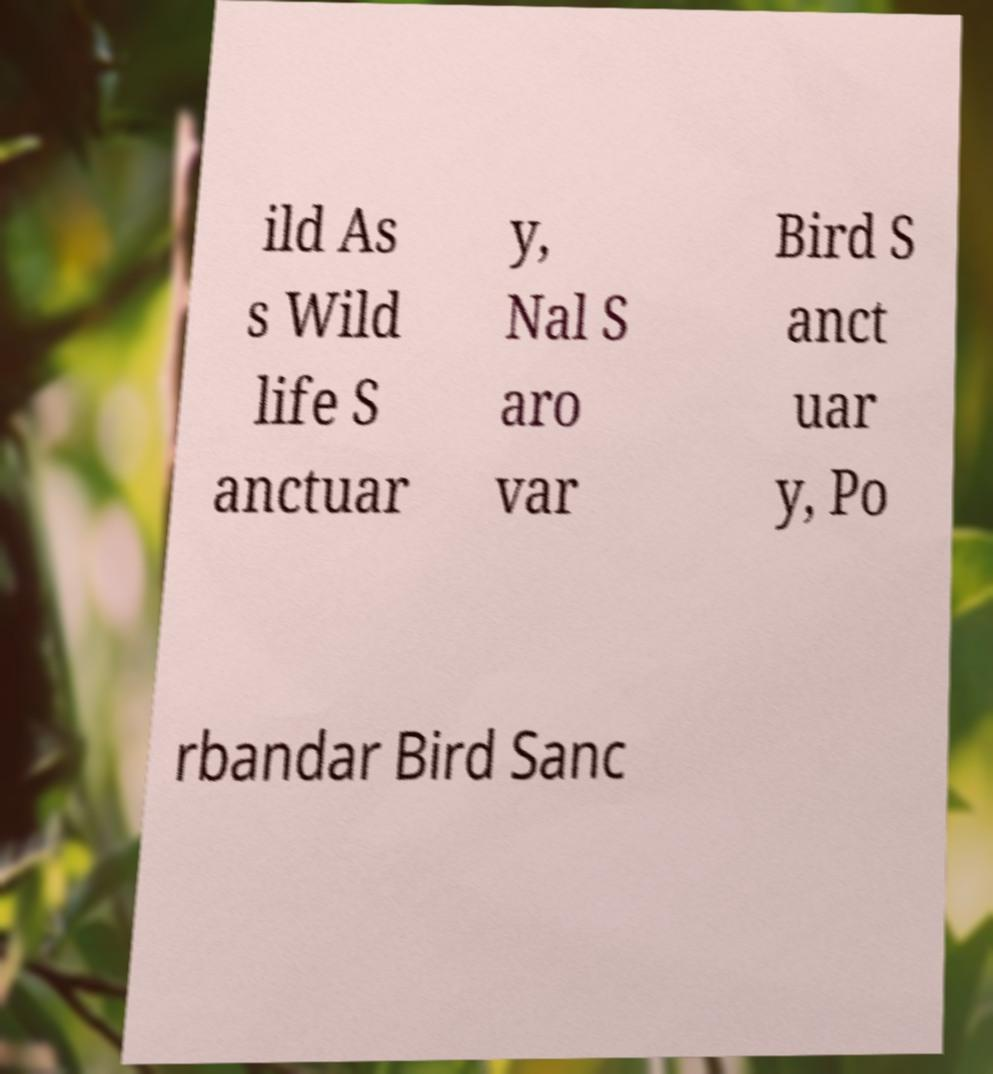There's text embedded in this image that I need extracted. Can you transcribe it verbatim? ild As s Wild life S anctuar y, Nal S aro var Bird S anct uar y, Po rbandar Bird Sanc 